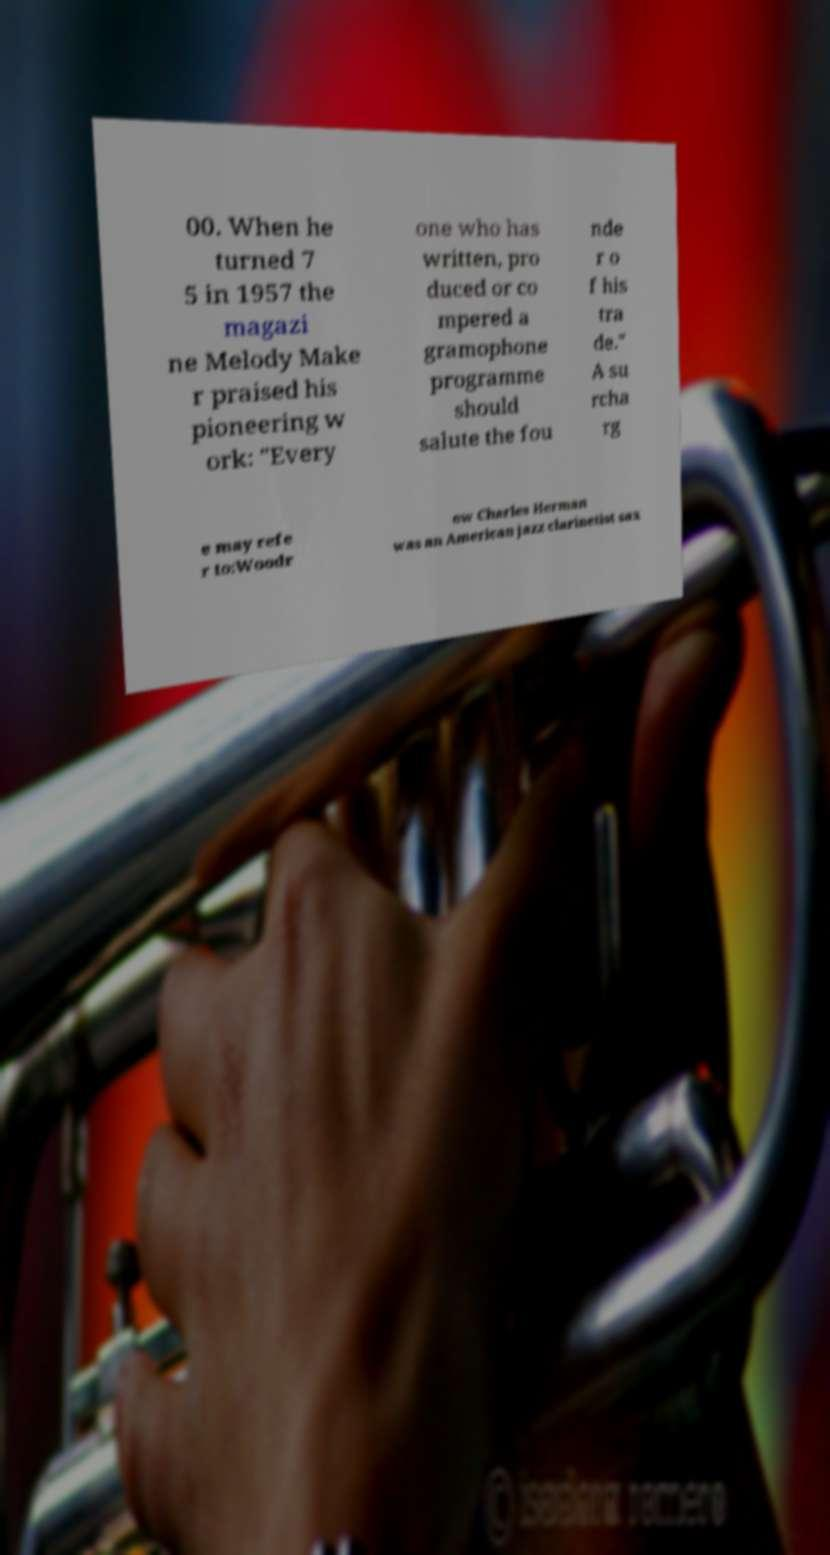Please read and relay the text visible in this image. What does it say? 00. When he turned 7 5 in 1957 the magazi ne Melody Make r praised his pioneering w ork: "Every one who has written, pro duced or co mpered a gramophone programme should salute the fou nde r o f his tra de." A su rcha rg e may refe r to:Woodr ow Charles Herman was an American jazz clarinetist sax 